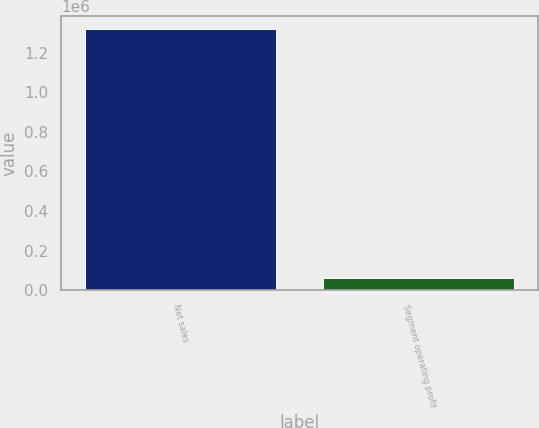Convert chart. <chart><loc_0><loc_0><loc_500><loc_500><bar_chart><fcel>Net sales<fcel>Segment operating profit<nl><fcel>1.31801e+06<fcel>60986<nl></chart> 